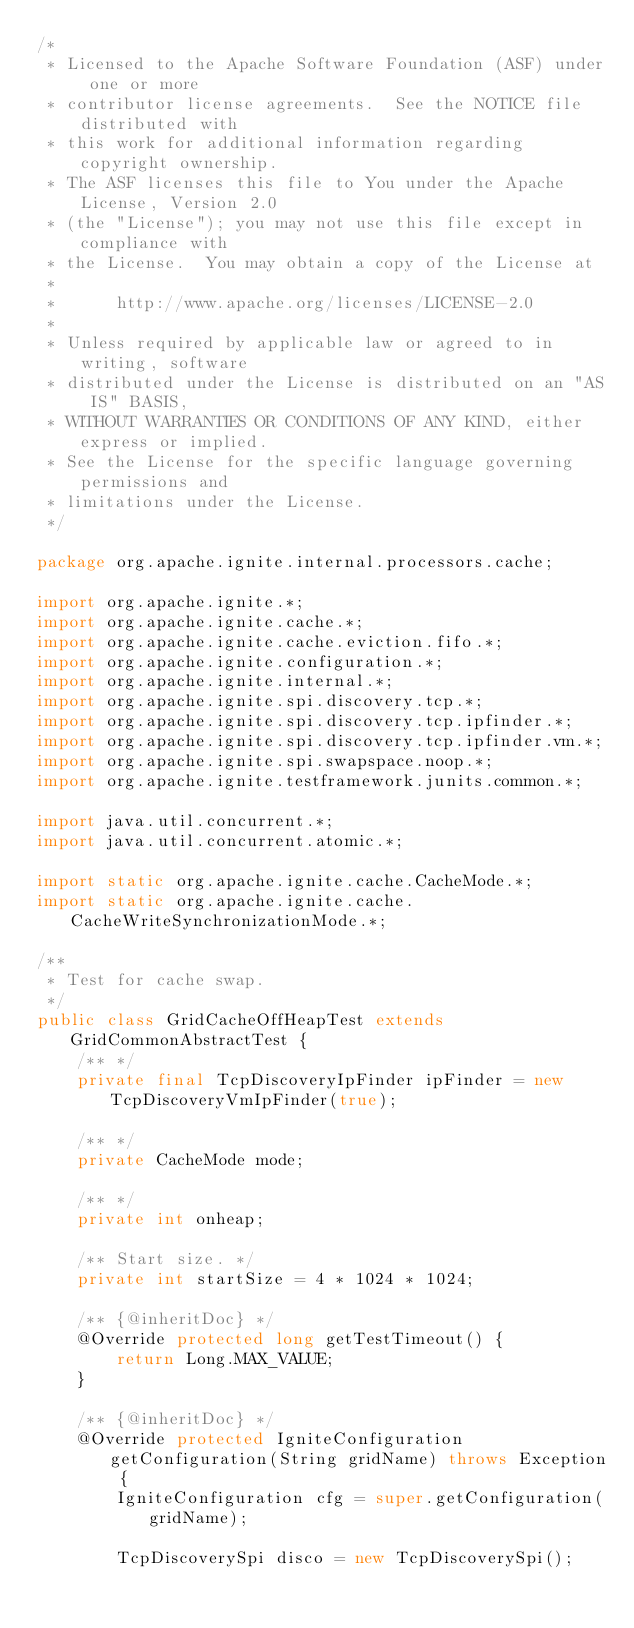<code> <loc_0><loc_0><loc_500><loc_500><_Java_>/*
 * Licensed to the Apache Software Foundation (ASF) under one or more
 * contributor license agreements.  See the NOTICE file distributed with
 * this work for additional information regarding copyright ownership.
 * The ASF licenses this file to You under the Apache License, Version 2.0
 * (the "License"); you may not use this file except in compliance with
 * the License.  You may obtain a copy of the License at
 *
 *      http://www.apache.org/licenses/LICENSE-2.0
 *
 * Unless required by applicable law or agreed to in writing, software
 * distributed under the License is distributed on an "AS IS" BASIS,
 * WITHOUT WARRANTIES OR CONDITIONS OF ANY KIND, either express or implied.
 * See the License for the specific language governing permissions and
 * limitations under the License.
 */

package org.apache.ignite.internal.processors.cache;

import org.apache.ignite.*;
import org.apache.ignite.cache.*;
import org.apache.ignite.cache.eviction.fifo.*;
import org.apache.ignite.configuration.*;
import org.apache.ignite.internal.*;
import org.apache.ignite.spi.discovery.tcp.*;
import org.apache.ignite.spi.discovery.tcp.ipfinder.*;
import org.apache.ignite.spi.discovery.tcp.ipfinder.vm.*;
import org.apache.ignite.spi.swapspace.noop.*;
import org.apache.ignite.testframework.junits.common.*;

import java.util.concurrent.*;
import java.util.concurrent.atomic.*;

import static org.apache.ignite.cache.CacheMode.*;
import static org.apache.ignite.cache.CacheWriteSynchronizationMode.*;

/**
 * Test for cache swap.
 */
public class GridCacheOffHeapTest extends GridCommonAbstractTest {
    /** */
    private final TcpDiscoveryIpFinder ipFinder = new TcpDiscoveryVmIpFinder(true);

    /** */
    private CacheMode mode;

    /** */
    private int onheap;

    /** Start size. */
    private int startSize = 4 * 1024 * 1024;

    /** {@inheritDoc} */
    @Override protected long getTestTimeout() {
        return Long.MAX_VALUE;
    }

    /** {@inheritDoc} */
    @Override protected IgniteConfiguration getConfiguration(String gridName) throws Exception {
        IgniteConfiguration cfg = super.getConfiguration(gridName);

        TcpDiscoverySpi disco = new TcpDiscoverySpi();
</code> 